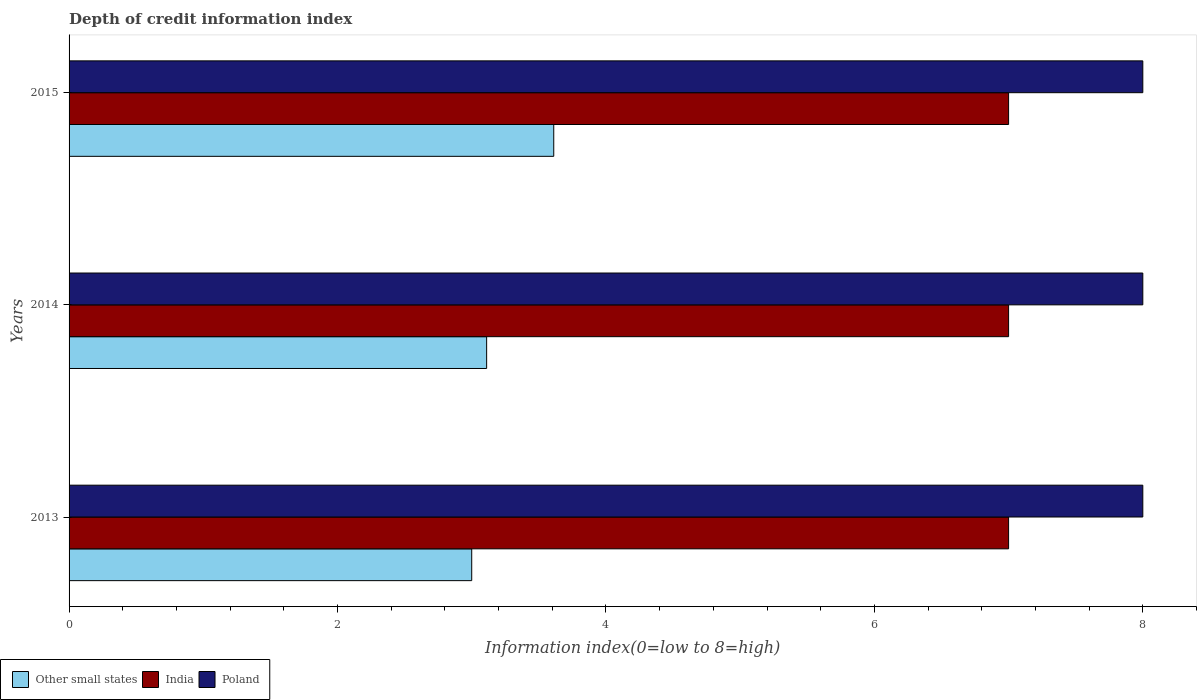How many different coloured bars are there?
Make the answer very short. 3. How many bars are there on the 1st tick from the top?
Offer a terse response. 3. What is the label of the 2nd group of bars from the top?
Make the answer very short. 2014. What is the information index in India in 2014?
Offer a terse response. 7. Across all years, what is the maximum information index in Poland?
Offer a terse response. 8. Across all years, what is the minimum information index in Poland?
Your answer should be very brief. 8. What is the total information index in India in the graph?
Provide a succinct answer. 21. What is the difference between the information index in India in 2014 and the information index in Other small states in 2015?
Your answer should be very brief. 3.39. What is the average information index in Other small states per year?
Your response must be concise. 3.24. In the year 2015, what is the difference between the information index in India and information index in Other small states?
Keep it short and to the point. 3.39. What is the ratio of the information index in Poland in 2013 to that in 2014?
Ensure brevity in your answer.  1. Is the difference between the information index in India in 2014 and 2015 greater than the difference between the information index in Other small states in 2014 and 2015?
Provide a succinct answer. Yes. What is the difference between the highest and the second highest information index in India?
Your answer should be very brief. 0. What is the difference between the highest and the lowest information index in India?
Offer a very short reply. 0. In how many years, is the information index in Poland greater than the average information index in Poland taken over all years?
Offer a terse response. 0. Is the sum of the information index in India in 2013 and 2014 greater than the maximum information index in Other small states across all years?
Ensure brevity in your answer.  Yes. What does the 2nd bar from the top in 2015 represents?
Make the answer very short. India. What does the 2nd bar from the bottom in 2014 represents?
Your answer should be compact. India. How many bars are there?
Provide a short and direct response. 9. Are the values on the major ticks of X-axis written in scientific E-notation?
Ensure brevity in your answer.  No. Does the graph contain any zero values?
Your answer should be compact. No. Does the graph contain grids?
Make the answer very short. No. How many legend labels are there?
Ensure brevity in your answer.  3. How are the legend labels stacked?
Your answer should be compact. Horizontal. What is the title of the graph?
Provide a short and direct response. Depth of credit information index. Does "Aruba" appear as one of the legend labels in the graph?
Your answer should be very brief. No. What is the label or title of the X-axis?
Offer a very short reply. Information index(0=low to 8=high). What is the label or title of the Y-axis?
Offer a very short reply. Years. What is the Information index(0=low to 8=high) of Poland in 2013?
Provide a succinct answer. 8. What is the Information index(0=low to 8=high) in Other small states in 2014?
Your answer should be compact. 3.11. What is the Information index(0=low to 8=high) of Other small states in 2015?
Make the answer very short. 3.61. Across all years, what is the maximum Information index(0=low to 8=high) in Other small states?
Your answer should be compact. 3.61. Across all years, what is the maximum Information index(0=low to 8=high) in India?
Provide a succinct answer. 7. Across all years, what is the minimum Information index(0=low to 8=high) of India?
Provide a short and direct response. 7. Across all years, what is the minimum Information index(0=low to 8=high) of Poland?
Ensure brevity in your answer.  8. What is the total Information index(0=low to 8=high) in Other small states in the graph?
Offer a terse response. 9.72. What is the total Information index(0=low to 8=high) in Poland in the graph?
Provide a succinct answer. 24. What is the difference between the Information index(0=low to 8=high) of Other small states in 2013 and that in 2014?
Offer a terse response. -0.11. What is the difference between the Information index(0=low to 8=high) in Poland in 2013 and that in 2014?
Ensure brevity in your answer.  0. What is the difference between the Information index(0=low to 8=high) of Other small states in 2013 and that in 2015?
Make the answer very short. -0.61. What is the difference between the Information index(0=low to 8=high) in India in 2013 and that in 2015?
Offer a terse response. 0. What is the difference between the Information index(0=low to 8=high) of Other small states in 2014 and that in 2015?
Offer a very short reply. -0.5. What is the difference between the Information index(0=low to 8=high) of Other small states in 2013 and the Information index(0=low to 8=high) of India in 2014?
Your answer should be compact. -4. What is the difference between the Information index(0=low to 8=high) of Other small states in 2014 and the Information index(0=low to 8=high) of India in 2015?
Keep it short and to the point. -3.89. What is the difference between the Information index(0=low to 8=high) in Other small states in 2014 and the Information index(0=low to 8=high) in Poland in 2015?
Ensure brevity in your answer.  -4.89. What is the difference between the Information index(0=low to 8=high) of India in 2014 and the Information index(0=low to 8=high) of Poland in 2015?
Provide a succinct answer. -1. What is the average Information index(0=low to 8=high) in Other small states per year?
Give a very brief answer. 3.24. What is the average Information index(0=low to 8=high) in Poland per year?
Your answer should be compact. 8. In the year 2013, what is the difference between the Information index(0=low to 8=high) in Other small states and Information index(0=low to 8=high) in India?
Keep it short and to the point. -4. In the year 2013, what is the difference between the Information index(0=low to 8=high) in Other small states and Information index(0=low to 8=high) in Poland?
Offer a terse response. -5. In the year 2014, what is the difference between the Information index(0=low to 8=high) in Other small states and Information index(0=low to 8=high) in India?
Offer a very short reply. -3.89. In the year 2014, what is the difference between the Information index(0=low to 8=high) in Other small states and Information index(0=low to 8=high) in Poland?
Keep it short and to the point. -4.89. In the year 2015, what is the difference between the Information index(0=low to 8=high) in Other small states and Information index(0=low to 8=high) in India?
Your response must be concise. -3.39. In the year 2015, what is the difference between the Information index(0=low to 8=high) of Other small states and Information index(0=low to 8=high) of Poland?
Ensure brevity in your answer.  -4.39. What is the ratio of the Information index(0=low to 8=high) in Other small states in 2013 to that in 2015?
Your answer should be very brief. 0.83. What is the ratio of the Information index(0=low to 8=high) in India in 2013 to that in 2015?
Provide a short and direct response. 1. What is the ratio of the Information index(0=low to 8=high) of Other small states in 2014 to that in 2015?
Your answer should be compact. 0.86. What is the ratio of the Information index(0=low to 8=high) in India in 2014 to that in 2015?
Give a very brief answer. 1. What is the difference between the highest and the second highest Information index(0=low to 8=high) of India?
Offer a terse response. 0. What is the difference between the highest and the second highest Information index(0=low to 8=high) of Poland?
Make the answer very short. 0. What is the difference between the highest and the lowest Information index(0=low to 8=high) of Other small states?
Give a very brief answer. 0.61. What is the difference between the highest and the lowest Information index(0=low to 8=high) in Poland?
Offer a very short reply. 0. 